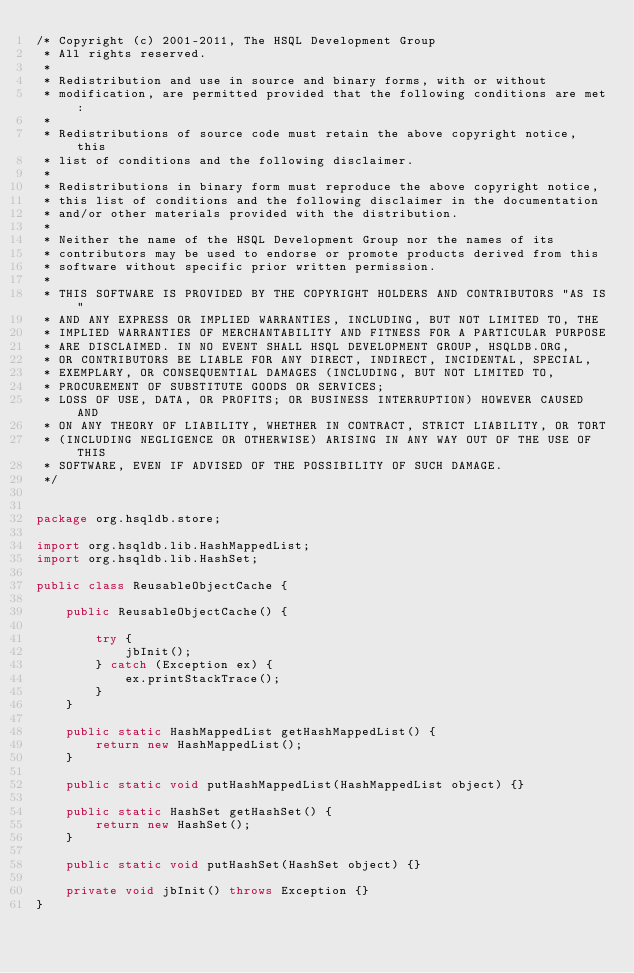Convert code to text. <code><loc_0><loc_0><loc_500><loc_500><_Java_>/* Copyright (c) 2001-2011, The HSQL Development Group
 * All rights reserved.
 *
 * Redistribution and use in source and binary forms, with or without
 * modification, are permitted provided that the following conditions are met:
 *
 * Redistributions of source code must retain the above copyright notice, this
 * list of conditions and the following disclaimer.
 *
 * Redistributions in binary form must reproduce the above copyright notice,
 * this list of conditions and the following disclaimer in the documentation
 * and/or other materials provided with the distribution.
 *
 * Neither the name of the HSQL Development Group nor the names of its
 * contributors may be used to endorse or promote products derived from this
 * software without specific prior written permission.
 *
 * THIS SOFTWARE IS PROVIDED BY THE COPYRIGHT HOLDERS AND CONTRIBUTORS "AS IS"
 * AND ANY EXPRESS OR IMPLIED WARRANTIES, INCLUDING, BUT NOT LIMITED TO, THE
 * IMPLIED WARRANTIES OF MERCHANTABILITY AND FITNESS FOR A PARTICULAR PURPOSE
 * ARE DISCLAIMED. IN NO EVENT SHALL HSQL DEVELOPMENT GROUP, HSQLDB.ORG,
 * OR CONTRIBUTORS BE LIABLE FOR ANY DIRECT, INDIRECT, INCIDENTAL, SPECIAL,
 * EXEMPLARY, OR CONSEQUENTIAL DAMAGES (INCLUDING, BUT NOT LIMITED TO,
 * PROCUREMENT OF SUBSTITUTE GOODS OR SERVICES;
 * LOSS OF USE, DATA, OR PROFITS; OR BUSINESS INTERRUPTION) HOWEVER CAUSED AND
 * ON ANY THEORY OF LIABILITY, WHETHER IN CONTRACT, STRICT LIABILITY, OR TORT
 * (INCLUDING NEGLIGENCE OR OTHERWISE) ARISING IN ANY WAY OUT OF THE USE OF THIS
 * SOFTWARE, EVEN IF ADVISED OF THE POSSIBILITY OF SUCH DAMAGE.
 */


package org.hsqldb.store;

import org.hsqldb.lib.HashMappedList;
import org.hsqldb.lib.HashSet;

public class ReusableObjectCache {

    public ReusableObjectCache() {

        try {
            jbInit();
        } catch (Exception ex) {
            ex.printStackTrace();
        }
    }

    public static HashMappedList getHashMappedList() {
        return new HashMappedList();
    }

    public static void putHashMappedList(HashMappedList object) {}

    public static HashSet getHashSet() {
        return new HashSet();
    }

    public static void putHashSet(HashSet object) {}

    private void jbInit() throws Exception {}
}
</code> 